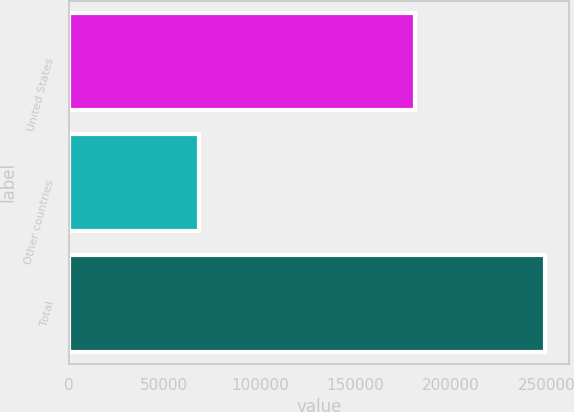Convert chart to OTSL. <chart><loc_0><loc_0><loc_500><loc_500><bar_chart><fcel>United States<fcel>Other countries<fcel>Total<nl><fcel>181019<fcel>68079<fcel>249098<nl></chart> 